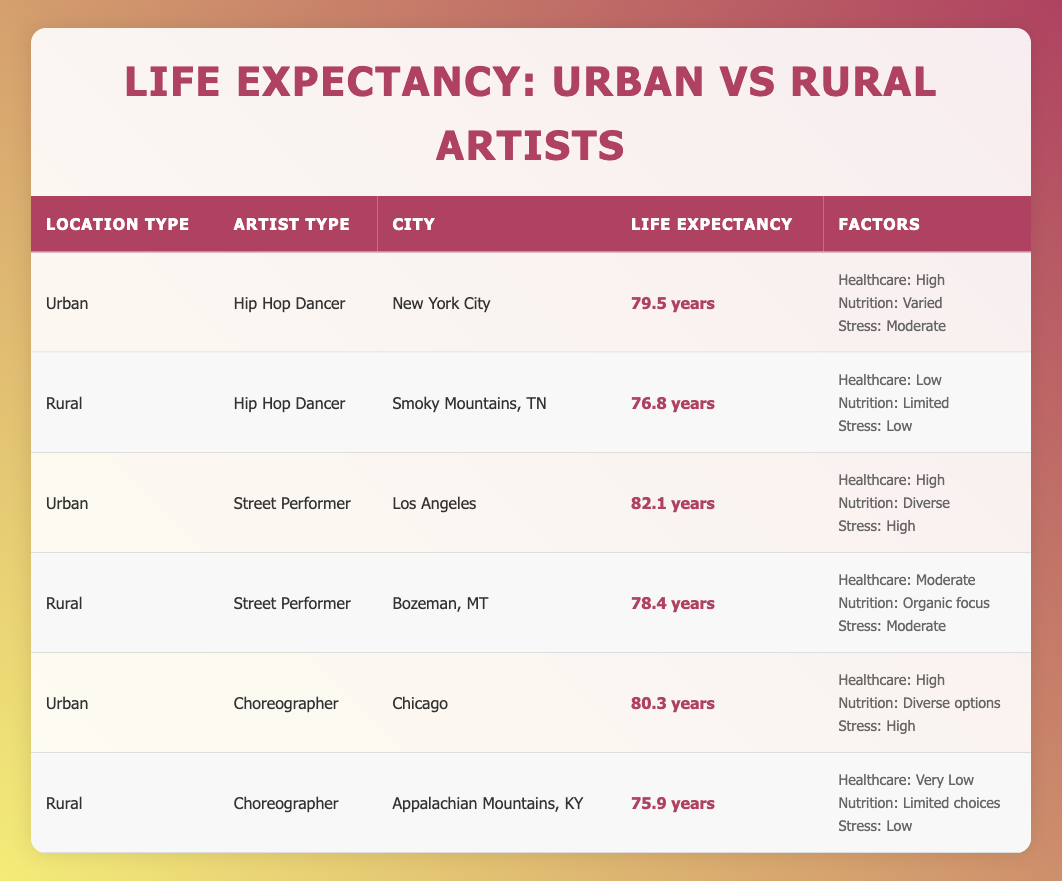What is the average life expectancy of urban hip hop dancers? From the table, the average life expectancy for urban hip hop dancers in New York City is listed as 79.5 years.
Answer: 79.5 years How does the life expectancy of rural street performers compare to urban street performers? The life expectancy of rural street performers in Bozeman, MT is 78.4 years, while urban street performers in Los Angeles have a life expectancy of 82.1 years. The difference is 82.1 - 78.4 = 3.7 years.
Answer: 3.7 years Is the average life expectancy of choreographers higher in urban areas than in rural areas? Urban choreographers in Chicago have an average life expectancy of 80.3 years, while rural choreographers in the Appalachian Mountains, KY have an average life expectancy of 75.9 years. Therefore, urban choreographers do have a higher average life expectancy.
Answer: Yes What is the total average life expectancy of all artist types in urban areas? The average life expectancy for urban artists is calculated by summing 79.5 (hip hop dancer) + 82.1 (street performer) + 80.3 (choreographer) = 241.9 years and dividing by 3 (number of urban artist types), yielding an average of 241.9 / 3 = 80.63 years.
Answer: 80.63 years Which artist type has the lowest average life expectancy in rural areas? The table shows that rural choreographers in the Appalachian Mountains, KY have the lowest life expectancy at 75.9 years compared to the rural hip hop dancer (76.8 years) and street performer (78.4 years).
Answer: Choreographer What is the difference in access to healthcare between urban and rural hip hop dancers? Urban hip hop dancers have high access to healthcare, while rural hip hop dancers have low access. The difference can be categorized as significant, indicating that urban dancers have better healthcare options.
Answer: Significant difference Are stress levels generally higher for urban dancers than for rural dancers? The urban hip hop dancer in New York City has moderate stress levels, while the rural hip hop dancer in Smoky Mountains, TN has low stress levels, making a general comparison suggest that urban dancers experience higher stress.
Answer: Yes What is the difference in life expectancy between street performers and hip hop dancers in urban areas? The urban street performer in Los Angeles has an average life expectancy of 82.1 years, while the urban hip hop dancer in New York City has an average of 79.5 years. The difference is 82.1 - 79.5 = 2.6 years.
Answer: 2.6 years 